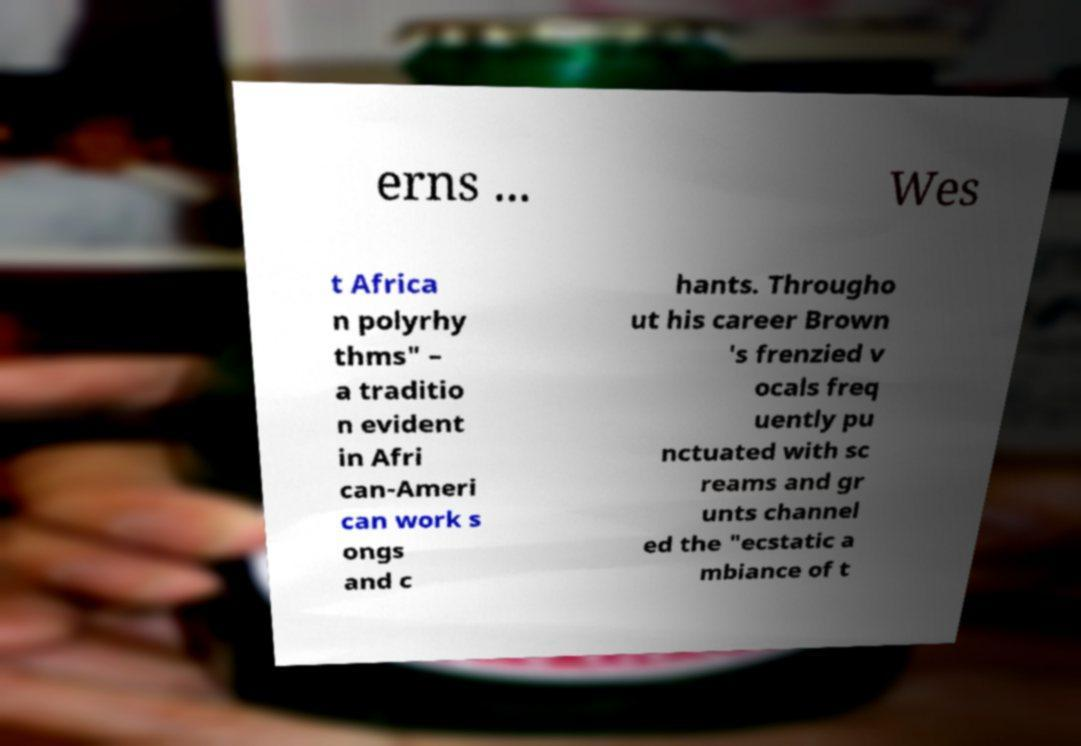What messages or text are displayed in this image? I need them in a readable, typed format. erns ... Wes t Africa n polyrhy thms" – a traditio n evident in Afri can-Ameri can work s ongs and c hants. Througho ut his career Brown 's frenzied v ocals freq uently pu nctuated with sc reams and gr unts channel ed the "ecstatic a mbiance of t 